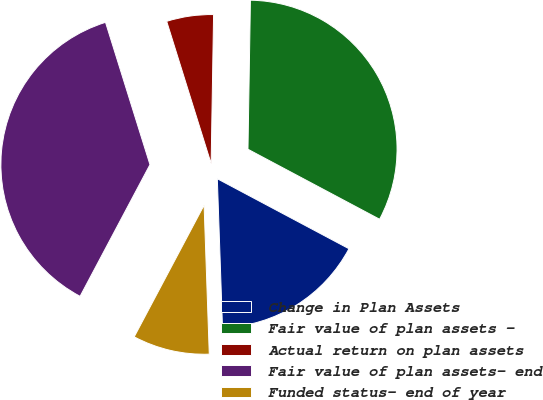Convert chart to OTSL. <chart><loc_0><loc_0><loc_500><loc_500><pie_chart><fcel>Change in Plan Assets<fcel>Fair value of plan assets -<fcel>Actual return on plan assets<fcel>Fair value of plan assets- end<fcel>Funded status- end of year<nl><fcel>16.67%<fcel>32.52%<fcel>5.08%<fcel>37.42%<fcel>8.32%<nl></chart> 